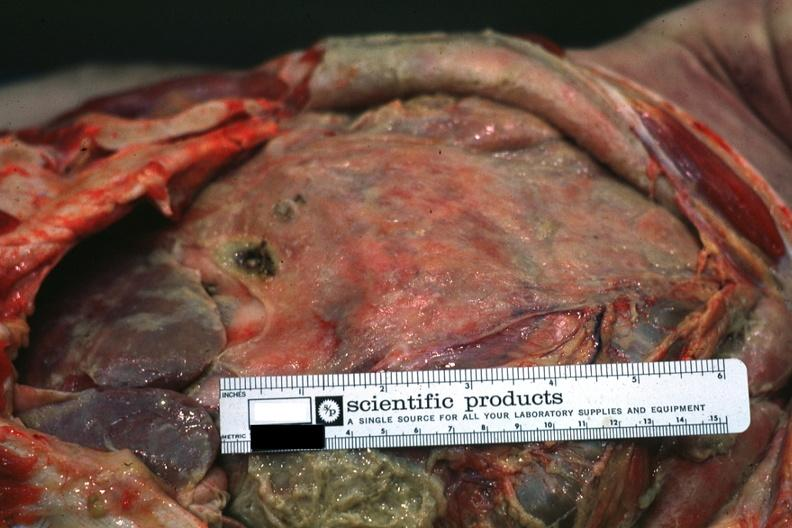what is present?
Answer the question using a single word or phrase. Acute peritonitis 